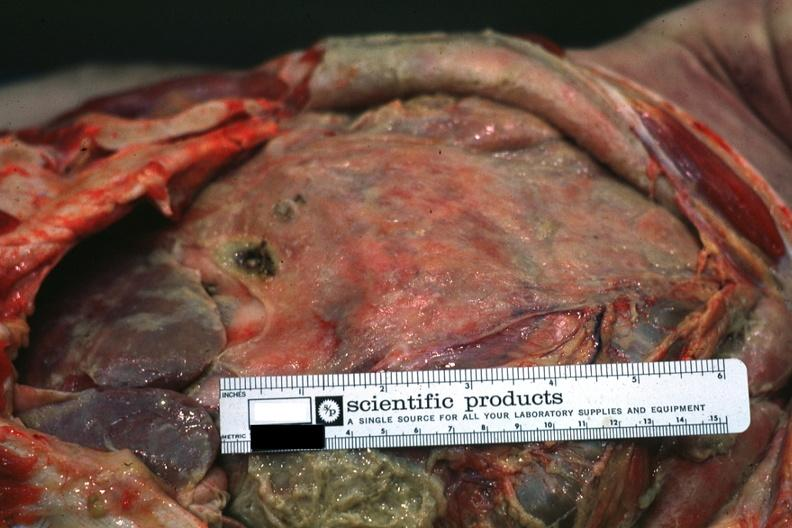what is present?
Answer the question using a single word or phrase. Acute peritonitis 